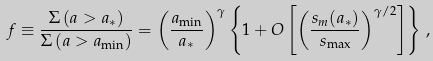<formula> <loc_0><loc_0><loc_500><loc_500>f \equiv \frac { \Sigma \, ( a > a _ { * } ) } { \Sigma \, ( a > a _ { \min } ) } = \left ( \frac { a _ { \min } } { a _ { * } } \right ) ^ { \gamma } \left \{ 1 + O \left [ \left ( \frac { s _ { m } ( a _ { * } ) } { s _ { \max } } \right ) ^ { \gamma / 2 } \right ] \right \} \, ,</formula> 